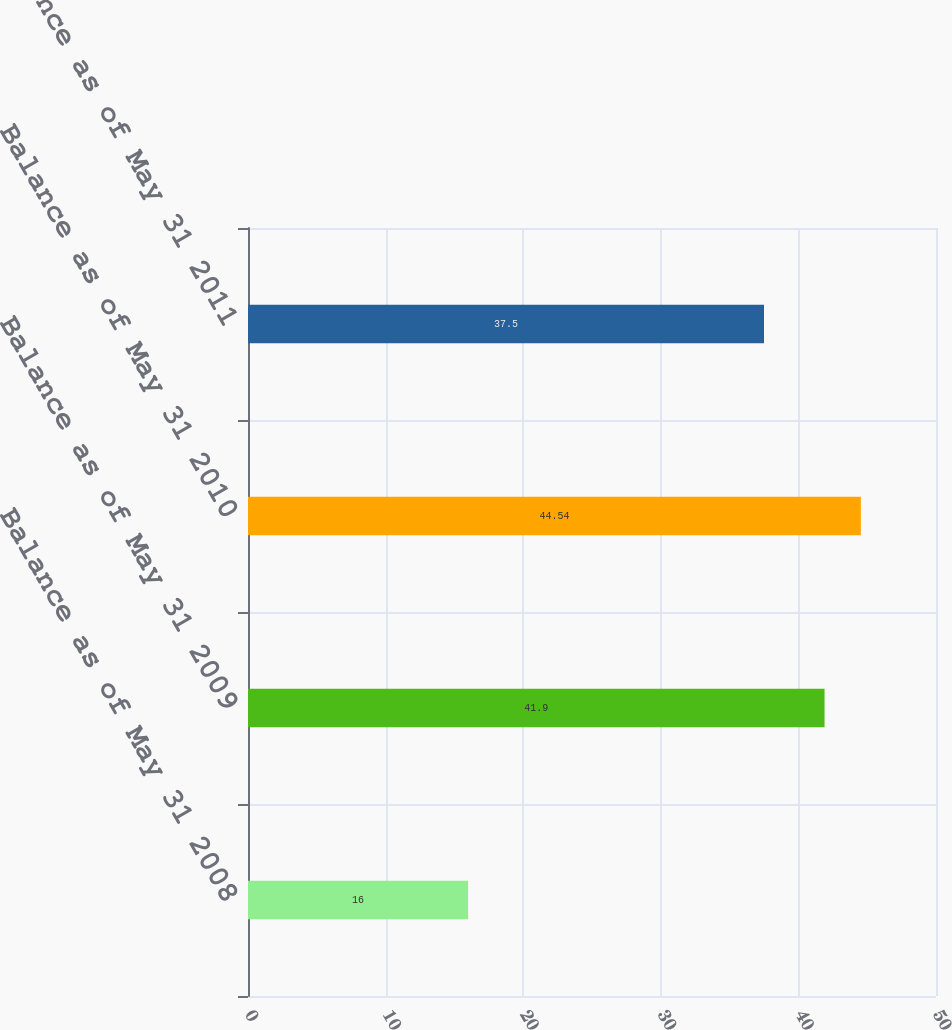Convert chart. <chart><loc_0><loc_0><loc_500><loc_500><bar_chart><fcel>Balance as of May 31 2008<fcel>Balance as of May 31 2009<fcel>Balance as of May 31 2010<fcel>Balance as of May 31 2011<nl><fcel>16<fcel>41.9<fcel>44.54<fcel>37.5<nl></chart> 